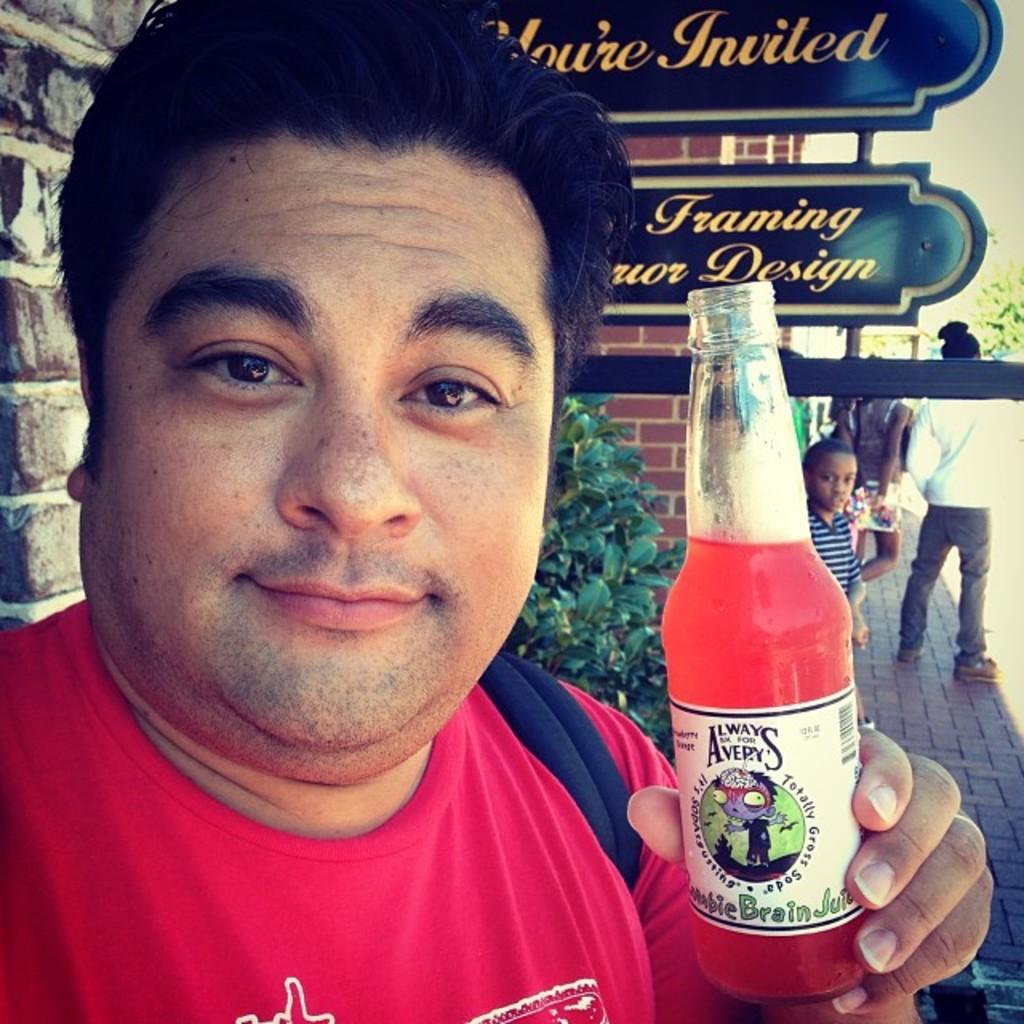Could you give a brief overview of what you see in this image? In this image i can see a man wearing a red t shirt holding a bottle, and in the background i can see boards and few people standing, and i can also see a wall and plants. 